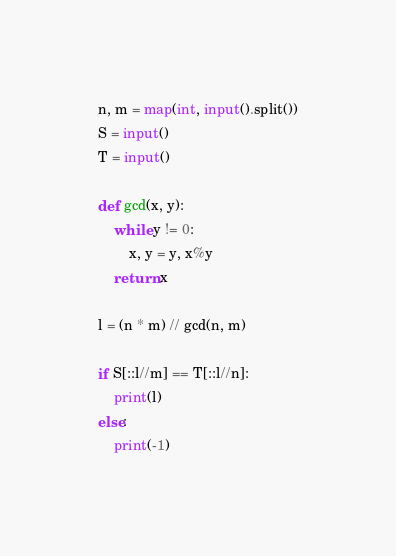Convert code to text. <code><loc_0><loc_0><loc_500><loc_500><_Python_>n, m = map(int, input().split())
S = input()
T = input()

def gcd(x, y):
    while y != 0:
        x, y = y, x%y
    return x

l = (n * m) // gcd(n, m)

if S[::l//m] == T[::l//n]:
    print(l)
else:
    print(-1)</code> 